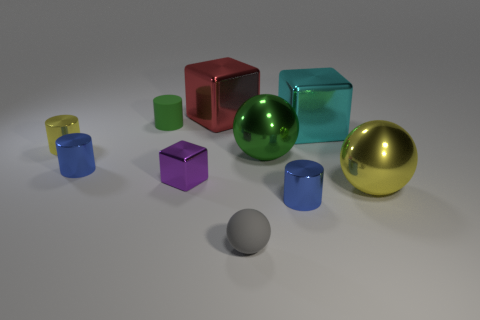How is the lighting arranged in this scene? The lighting in the scene suggests a single light source above the objects, generating softly diffused shadows that are cast downward. There's an even illumination indicating the light source is broad and not too close to the objects. 